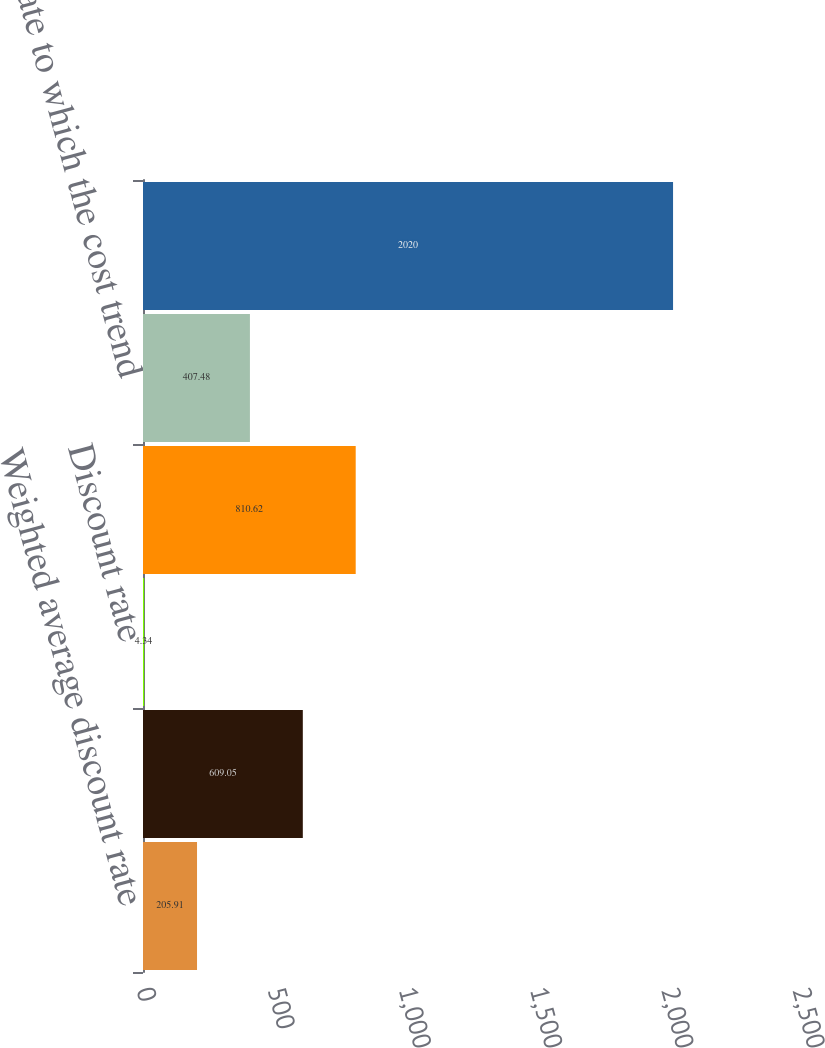Convert chart to OTSL. <chart><loc_0><loc_0><loc_500><loc_500><bar_chart><fcel>Weighted average discount rate<fcel>Long-term rate of return on<fcel>Discount rate<fcel>Health care cost trend rate<fcel>Rate to which the cost trend<fcel>Year that the rate reaches the<nl><fcel>205.91<fcel>609.05<fcel>4.34<fcel>810.62<fcel>407.48<fcel>2020<nl></chart> 